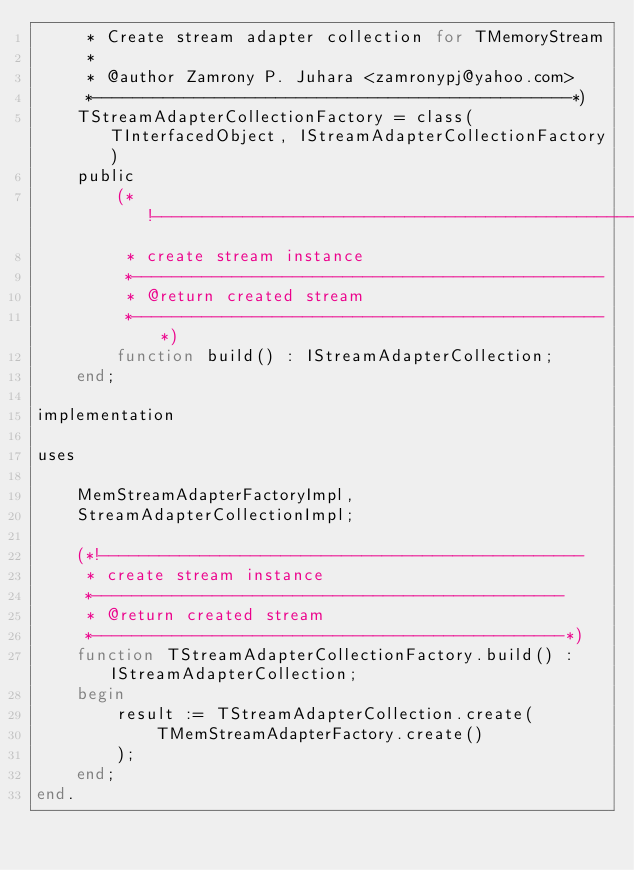Convert code to text. <code><loc_0><loc_0><loc_500><loc_500><_Pascal_>     * Create stream adapter collection for TMemoryStream
     *
     * @author Zamrony P. Juhara <zamronypj@yahoo.com>
     *-----------------------------------------------*)
    TStreamAdapterCollectionFactory = class(TInterfacedObject, IStreamAdapterCollectionFactory)
    public
        (*!------------------------------------------------
         * create stream instance
         *-----------------------------------------------
         * @return created stream
         *-----------------------------------------------*)
        function build() : IStreamAdapterCollection;
    end;

implementation

uses

    MemStreamAdapterFactoryImpl,
    StreamAdapterCollectionImpl;

    (*!------------------------------------------------
     * create stream instance
     *-----------------------------------------------
     * @return created stream
     *-----------------------------------------------*)
    function TStreamAdapterCollectionFactory.build() : IStreamAdapterCollection;
    begin
        result := TStreamAdapterCollection.create(
            TMemStreamAdapterFactory.create()
        );
    end;
end.
</code> 